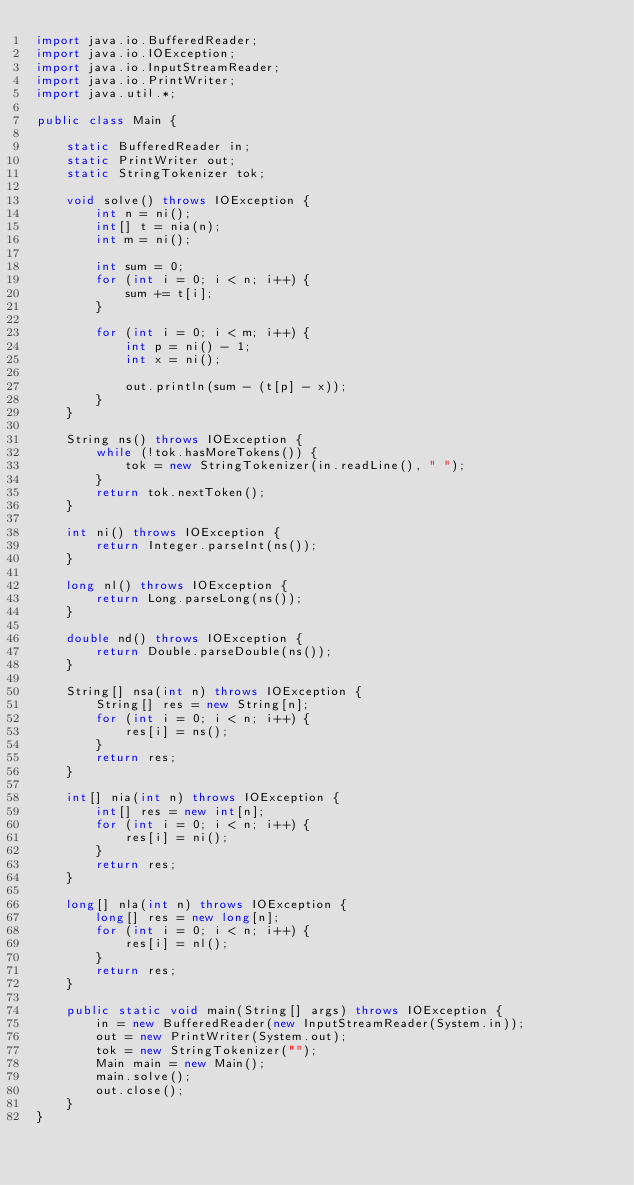<code> <loc_0><loc_0><loc_500><loc_500><_Java_>import java.io.BufferedReader;
import java.io.IOException;
import java.io.InputStreamReader;
import java.io.PrintWriter;
import java.util.*;

public class Main {

    static BufferedReader in;
    static PrintWriter out;
    static StringTokenizer tok;

    void solve() throws IOException {
        int n = ni();
        int[] t = nia(n);
        int m = ni();

        int sum = 0;
        for (int i = 0; i < n; i++) {
            sum += t[i];
        }

        for (int i = 0; i < m; i++) {
            int p = ni() - 1;
            int x = ni();

            out.println(sum - (t[p] - x));
        }
    }

    String ns() throws IOException {
        while (!tok.hasMoreTokens()) {
            tok = new StringTokenizer(in.readLine(), " ");
        }
        return tok.nextToken();
    }

    int ni() throws IOException {
        return Integer.parseInt(ns());
    }

    long nl() throws IOException {
        return Long.parseLong(ns());
    }

    double nd() throws IOException {
        return Double.parseDouble(ns());
    }

    String[] nsa(int n) throws IOException {
        String[] res = new String[n];
        for (int i = 0; i < n; i++) {
            res[i] = ns();
        }
        return res;
    }

    int[] nia(int n) throws IOException {
        int[] res = new int[n];
        for (int i = 0; i < n; i++) {
            res[i] = ni();
        }
        return res;
    }

    long[] nla(int n) throws IOException {
        long[] res = new long[n];
        for (int i = 0; i < n; i++) {
            res[i] = nl();
        }
        return res;
    }

    public static void main(String[] args) throws IOException {
        in = new BufferedReader(new InputStreamReader(System.in));
        out = new PrintWriter(System.out);
        tok = new StringTokenizer("");
        Main main = new Main();
        main.solve();
        out.close();
    }
}</code> 